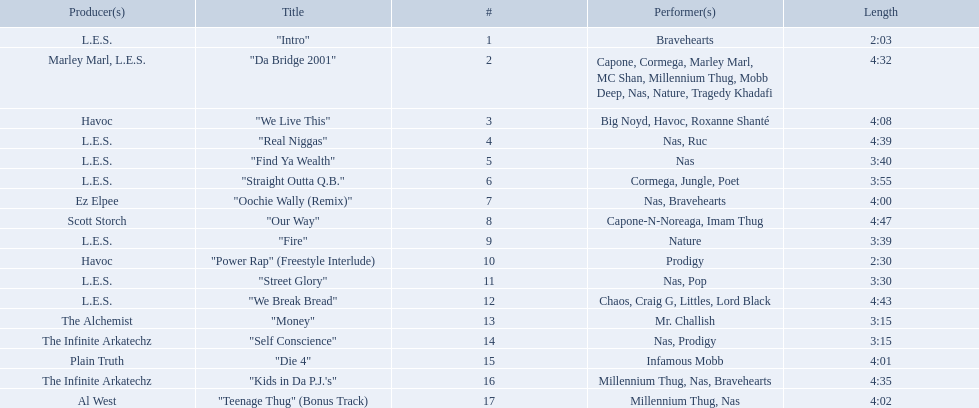What are the track times on the nas & ill will records presents qb's finest album? 2:03, 4:32, 4:08, 4:39, 3:40, 3:55, 4:00, 4:47, 3:39, 2:30, 3:30, 4:43, 3:15, 3:15, 4:01, 4:35, 4:02. Of those which is the longest? 4:47. 